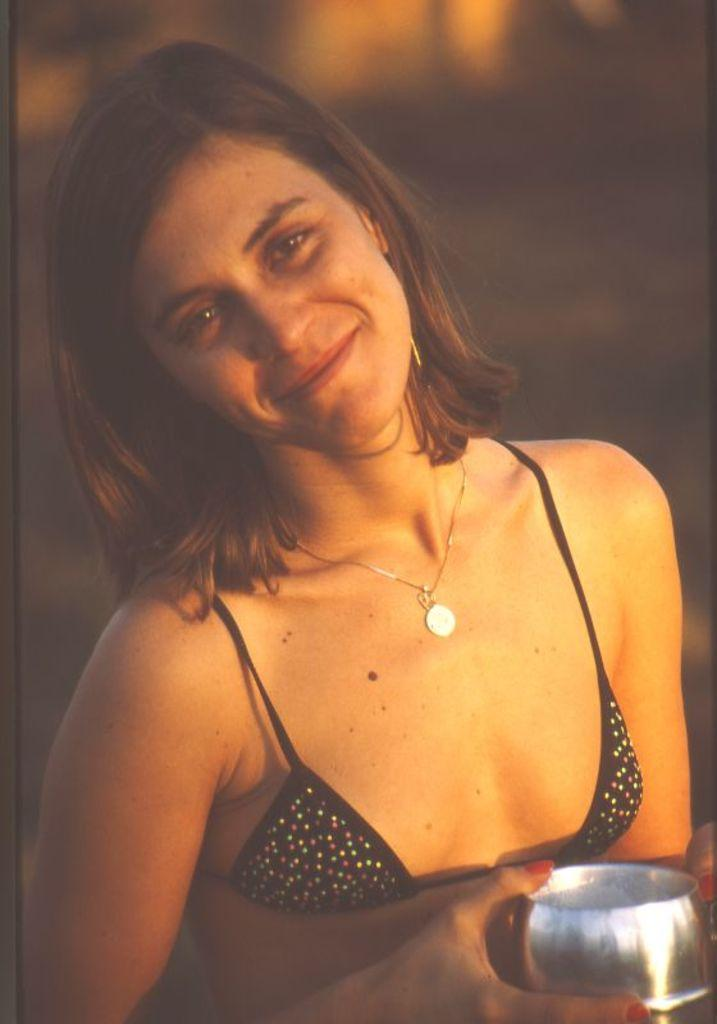Who is in the picture? There is a woman in the picture. What is the woman doing in the picture? The woman is smiling in the picture. What is the woman holding in her right hand? The woman is holding a stainless steel glass in her right hand. Can you describe any accessories the woman is wearing? There is a chain on the woman's neck. How many cows can be seen grazing in the background of the image? There are no cows present in the image; it features a woman smiling and holding a stainless steel glass. 